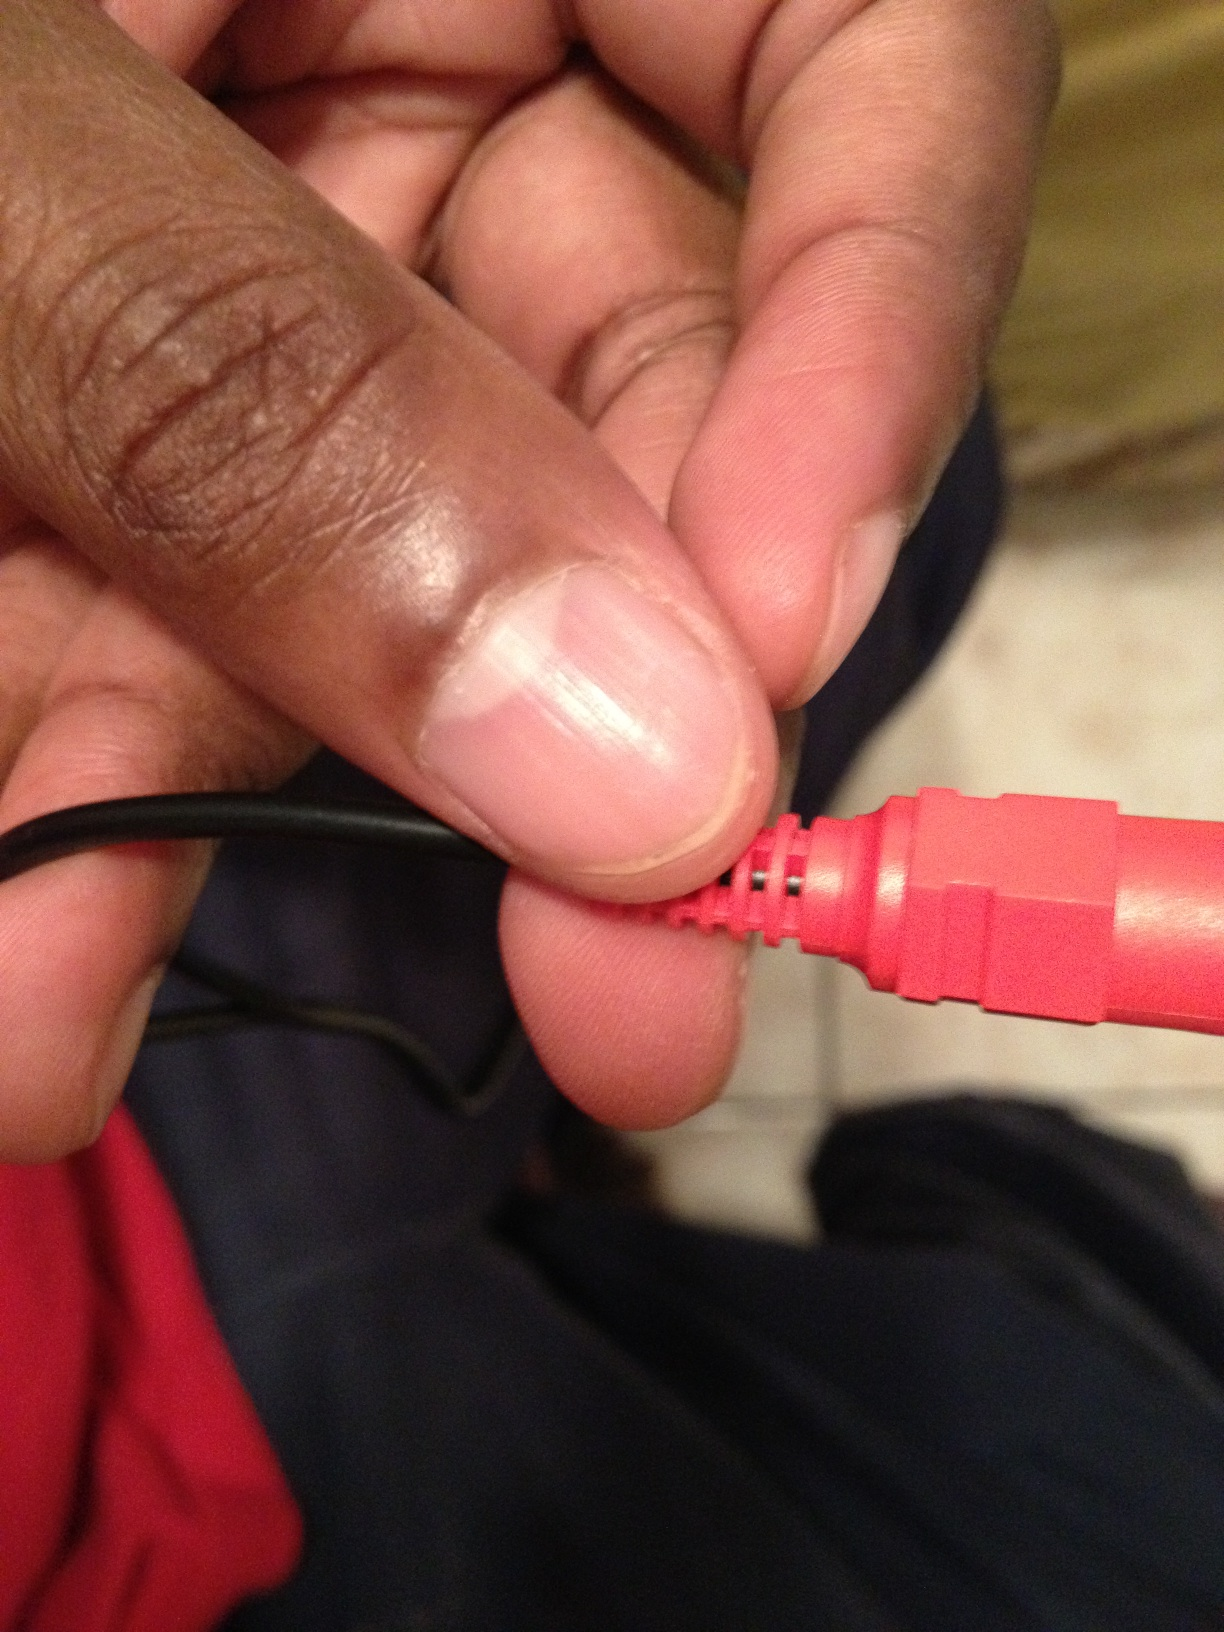Can you explain what this part might be used for? This connector pin is likely part of an audio or electronic device setup. It could be used to transfer audio signals between devices, connect speakers, or interface with another electronic component. How do you connect this type of pin to a device? To connect this type of pin, you need to locate the corresponding port on your device, usually marked with a matching color or symbol. Insert the pin gently but firmly, ensuring a secure connection without forcing it, to avoid damaging the connector or the port. 